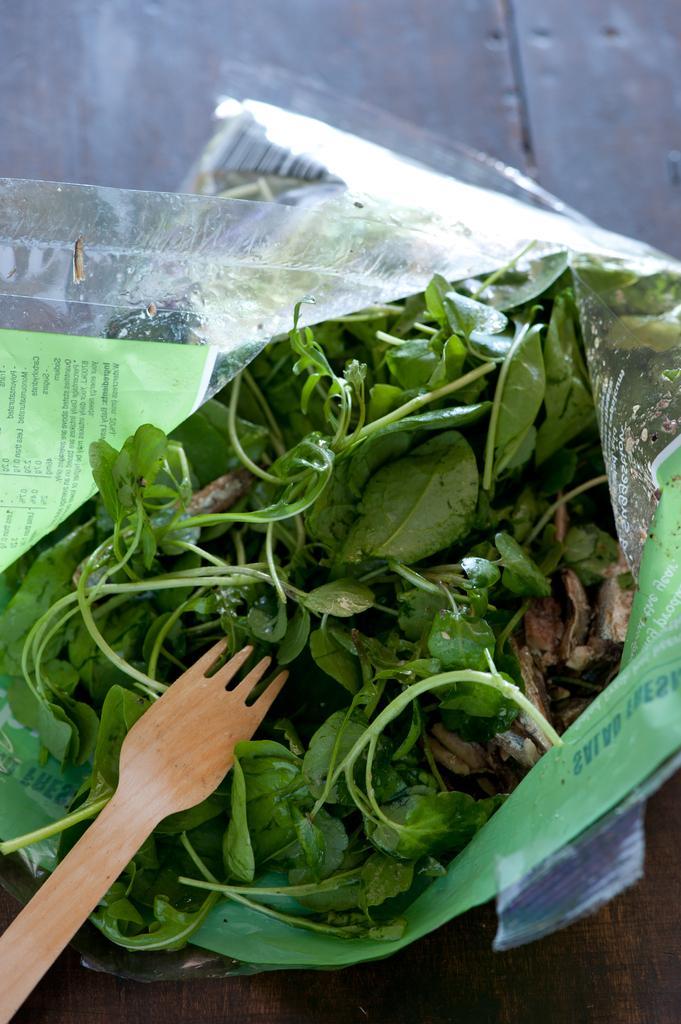How would you summarize this image in a sentence or two? In this given picture, We can see vegetable in a plastic bag and a wooden spoon. 